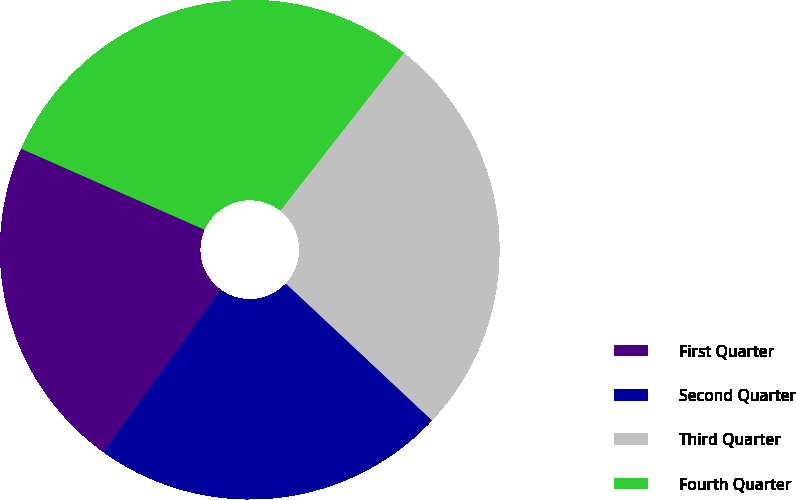<chart> <loc_0><loc_0><loc_500><loc_500><pie_chart><fcel>First Quarter<fcel>Second Quarter<fcel>Third Quarter<fcel>Fourth Quarter<nl><fcel>21.67%<fcel>22.97%<fcel>26.41%<fcel>28.95%<nl></chart> 